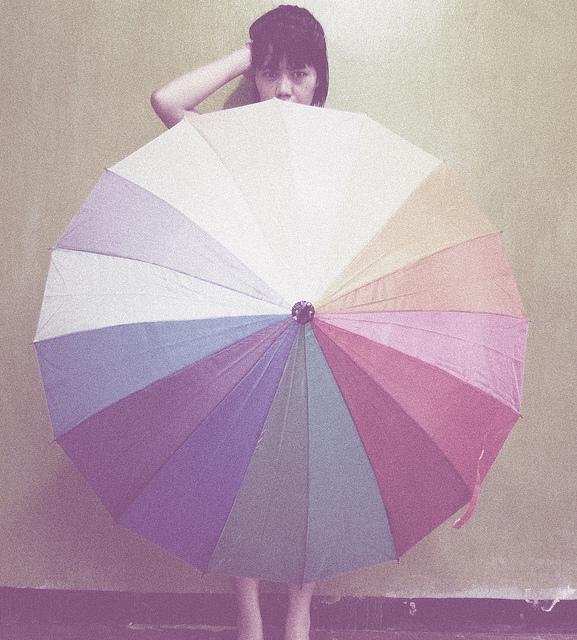What are the umbrellas made of?
Quick response, please. Cloth. Is the lady wearing a bikini?
Be succinct. No. How many different colors are on the umbrella?
Short answer required. 13. Who is behind the umbrella?
Write a very short answer. Woman. 